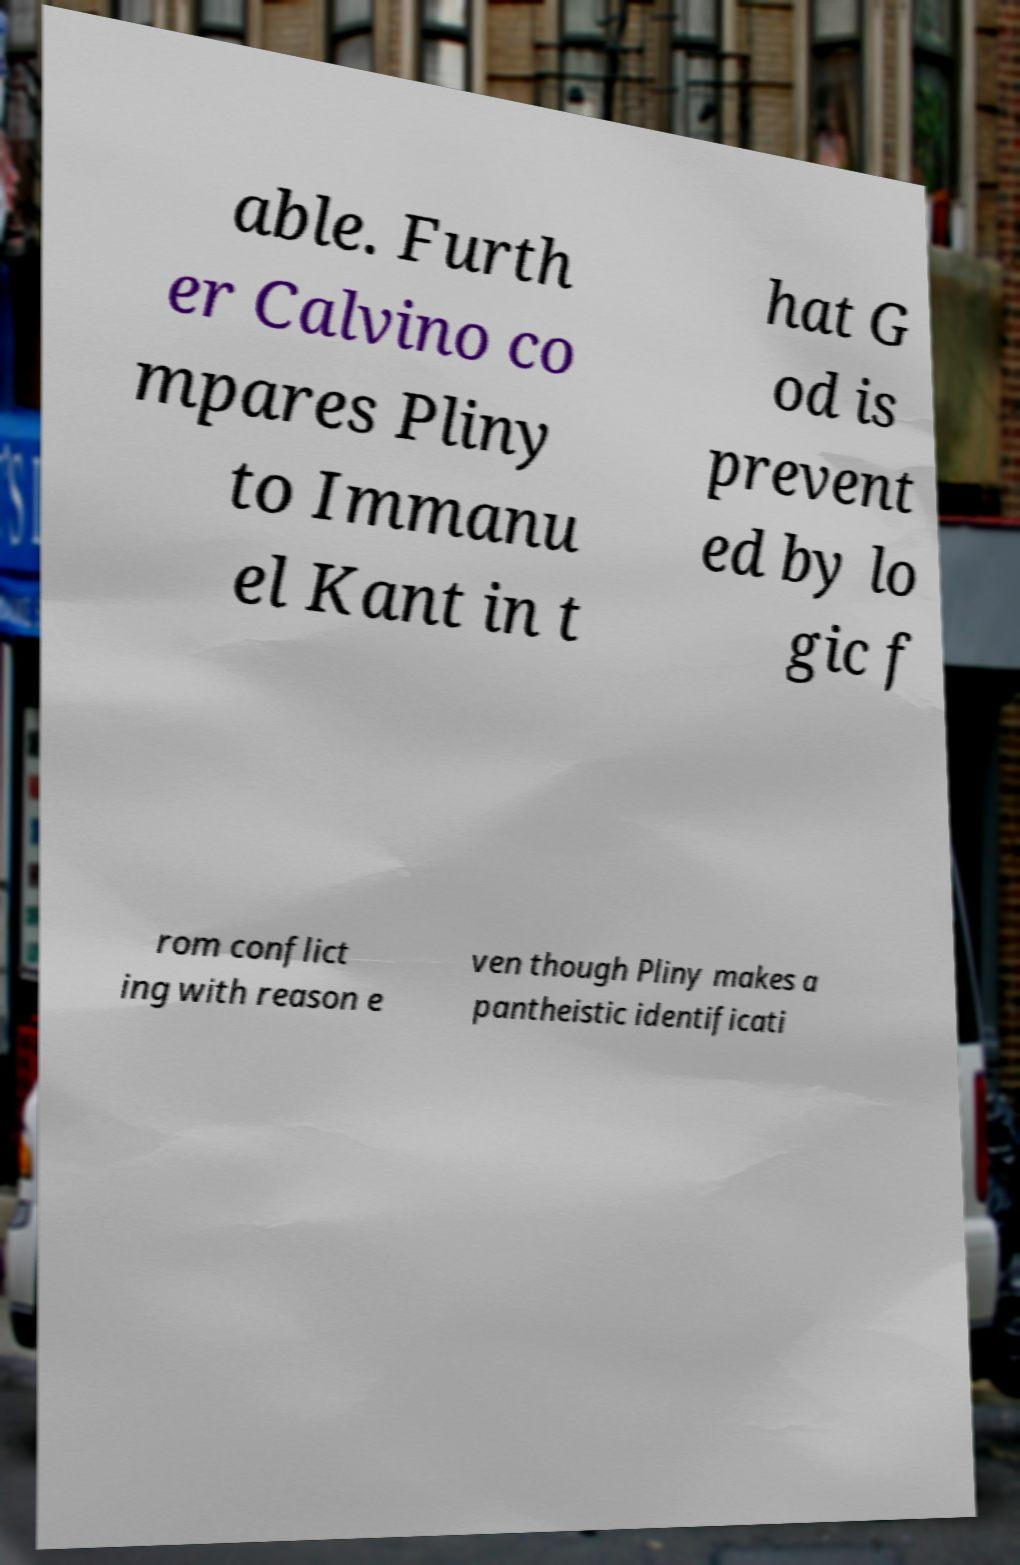For documentation purposes, I need the text within this image transcribed. Could you provide that? able. Furth er Calvino co mpares Pliny to Immanu el Kant in t hat G od is prevent ed by lo gic f rom conflict ing with reason e ven though Pliny makes a pantheistic identificati 